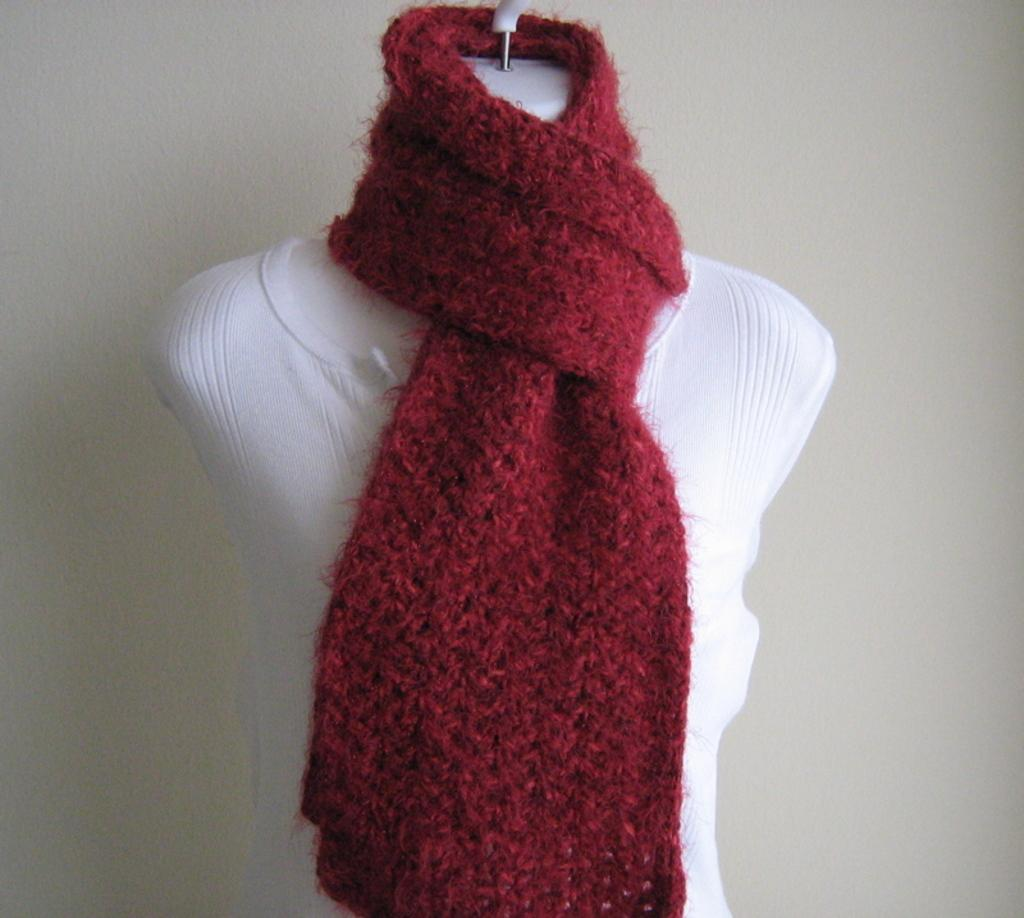What is the main subject in the image? There is a mannequin in the image. What is the mannequin wearing? The mannequin is wearing a cloth and a scarf. What can be seen in the background of the image? There is a wall in the background of the image. Is there any blood visible on the mannequin or the wall in the image? No, there is no blood visible on the mannequin or the wall in the image. Are there any icicles hanging from the wall in the image? No, there are no icicles present in the image. 